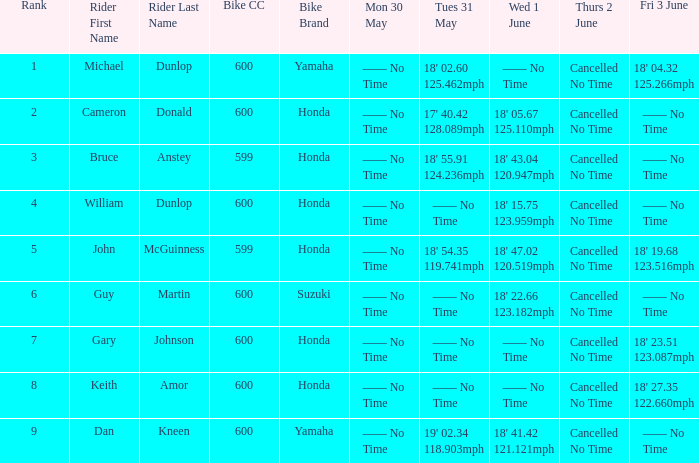Who was the rider with a Fri 3 June time of 18' 19.68 123.516mph? John McGuinness 599cc Honda. 